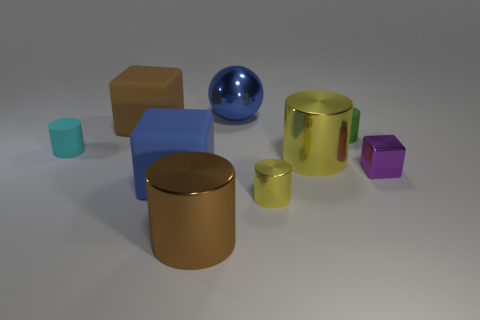Subtract all cyan balls. How many yellow cylinders are left? 2 Add 1 yellow metal cubes. How many objects exist? 10 Subtract all big yellow cylinders. How many cylinders are left? 4 Subtract all green cylinders. How many cylinders are left? 4 Subtract all blocks. How many objects are left? 6 Subtract 4 cylinders. How many cylinders are left? 1 Subtract 1 brown blocks. How many objects are left? 8 Subtract all yellow cubes. Subtract all green balls. How many cubes are left? 3 Subtract all large gray spheres. Subtract all cyan matte cylinders. How many objects are left? 8 Add 6 big shiny spheres. How many big shiny spheres are left? 7 